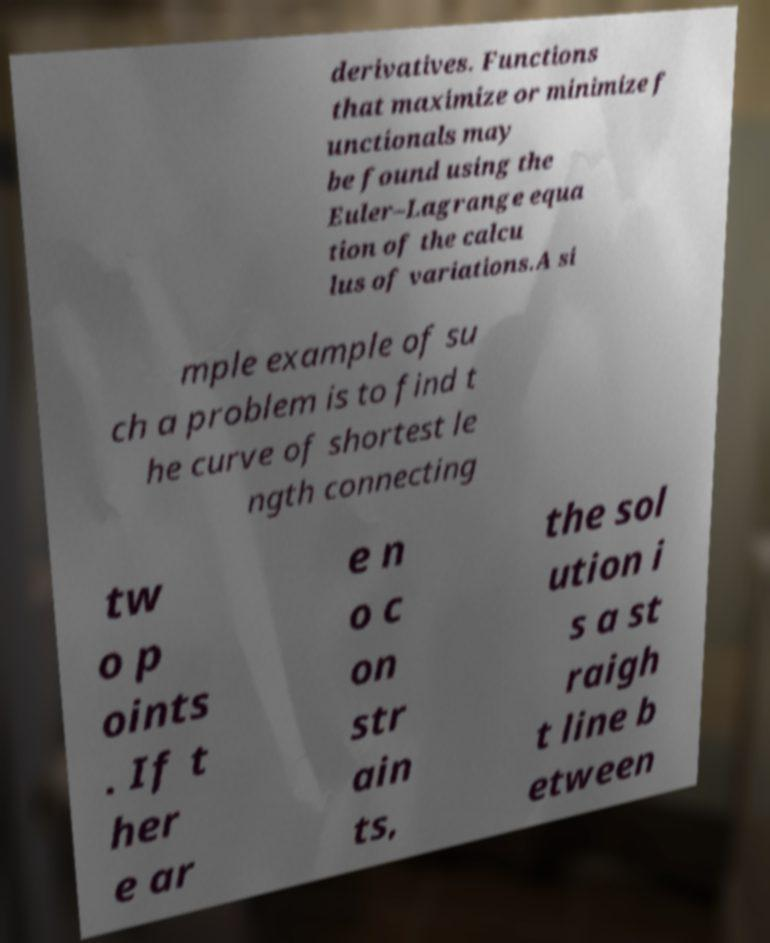I need the written content from this picture converted into text. Can you do that? derivatives. Functions that maximize or minimize f unctionals may be found using the Euler–Lagrange equa tion of the calcu lus of variations.A si mple example of su ch a problem is to find t he curve of shortest le ngth connecting tw o p oints . If t her e ar e n o c on str ain ts, the sol ution i s a st raigh t line b etween 